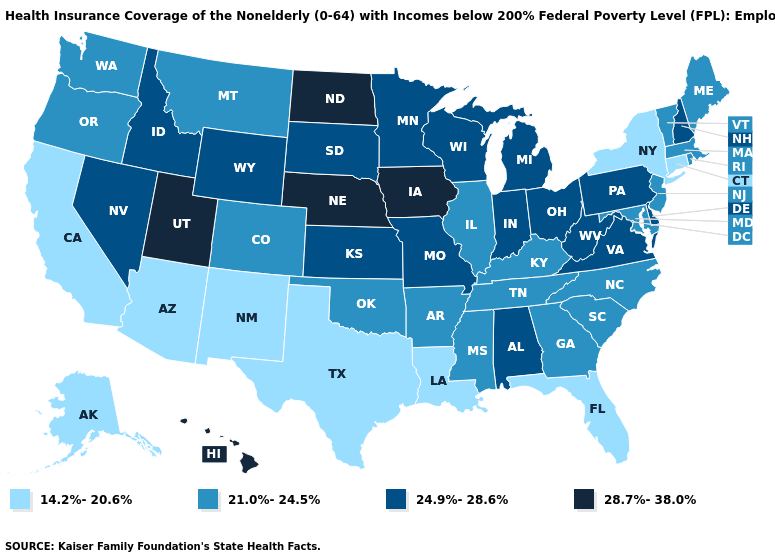Which states hav the highest value in the South?
Write a very short answer. Alabama, Delaware, Virginia, West Virginia. Among the states that border New York , which have the highest value?
Short answer required. Pennsylvania. Name the states that have a value in the range 21.0%-24.5%?
Quick response, please. Arkansas, Colorado, Georgia, Illinois, Kentucky, Maine, Maryland, Massachusetts, Mississippi, Montana, New Jersey, North Carolina, Oklahoma, Oregon, Rhode Island, South Carolina, Tennessee, Vermont, Washington. What is the highest value in the West ?
Short answer required. 28.7%-38.0%. Does Kentucky have the same value as Arkansas?
Short answer required. Yes. Name the states that have a value in the range 24.9%-28.6%?
Concise answer only. Alabama, Delaware, Idaho, Indiana, Kansas, Michigan, Minnesota, Missouri, Nevada, New Hampshire, Ohio, Pennsylvania, South Dakota, Virginia, West Virginia, Wisconsin, Wyoming. Name the states that have a value in the range 14.2%-20.6%?
Short answer required. Alaska, Arizona, California, Connecticut, Florida, Louisiana, New Mexico, New York, Texas. How many symbols are there in the legend?
Quick response, please. 4. What is the lowest value in the USA?
Give a very brief answer. 14.2%-20.6%. Does North Dakota have the highest value in the USA?
Short answer required. Yes. Among the states that border Florida , does Alabama have the lowest value?
Write a very short answer. No. What is the value of Vermont?
Concise answer only. 21.0%-24.5%. Name the states that have a value in the range 28.7%-38.0%?
Keep it brief. Hawaii, Iowa, Nebraska, North Dakota, Utah. Does the map have missing data?
Keep it brief. No. Does the first symbol in the legend represent the smallest category?
Concise answer only. Yes. 